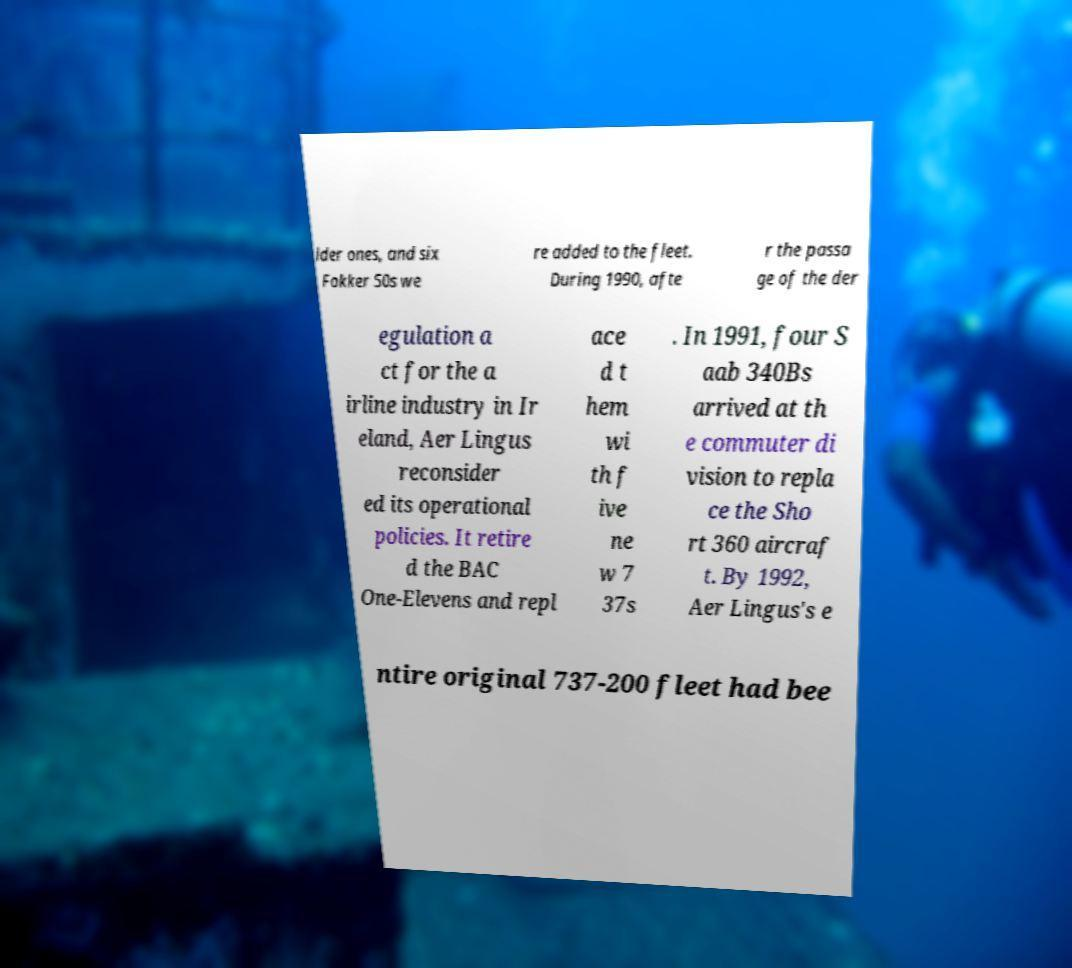Could you assist in decoding the text presented in this image and type it out clearly? lder ones, and six Fokker 50s we re added to the fleet. During 1990, afte r the passa ge of the der egulation a ct for the a irline industry in Ir eland, Aer Lingus reconsider ed its operational policies. It retire d the BAC One-Elevens and repl ace d t hem wi th f ive ne w 7 37s . In 1991, four S aab 340Bs arrived at th e commuter di vision to repla ce the Sho rt 360 aircraf t. By 1992, Aer Lingus's e ntire original 737-200 fleet had bee 